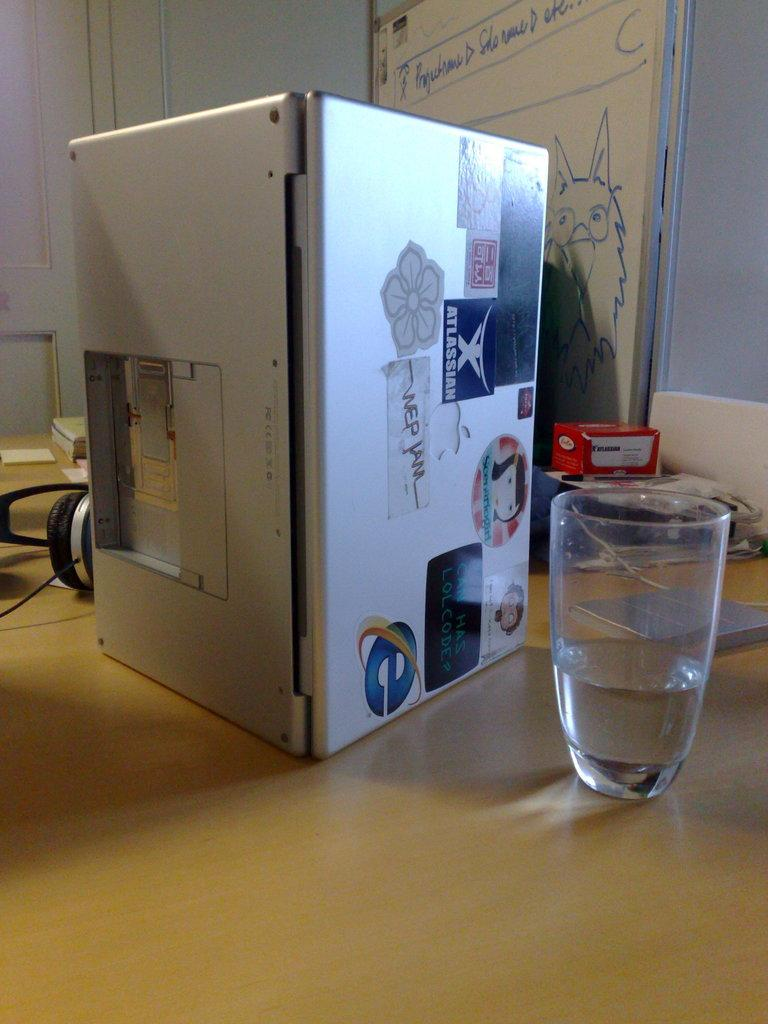<image>
Describe the image concisely. A Macbook is laying open on its side with an Atlassian sticker and other stickers on it. 